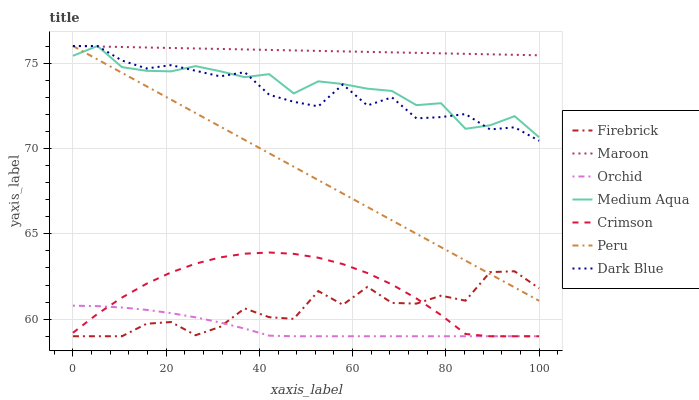Does Orchid have the minimum area under the curve?
Answer yes or no. Yes. Does Maroon have the maximum area under the curve?
Answer yes or no. Yes. Does Dark Blue have the minimum area under the curve?
Answer yes or no. No. Does Dark Blue have the maximum area under the curve?
Answer yes or no. No. Is Peru the smoothest?
Answer yes or no. Yes. Is Firebrick the roughest?
Answer yes or no. Yes. Is Maroon the smoothest?
Answer yes or no. No. Is Maroon the roughest?
Answer yes or no. No. Does Firebrick have the lowest value?
Answer yes or no. Yes. Does Dark Blue have the lowest value?
Answer yes or no. No. Does Peru have the highest value?
Answer yes or no. Yes. Does Crimson have the highest value?
Answer yes or no. No. Is Orchid less than Dark Blue?
Answer yes or no. Yes. Is Maroon greater than Firebrick?
Answer yes or no. Yes. Does Firebrick intersect Orchid?
Answer yes or no. Yes. Is Firebrick less than Orchid?
Answer yes or no. No. Is Firebrick greater than Orchid?
Answer yes or no. No. Does Orchid intersect Dark Blue?
Answer yes or no. No. 